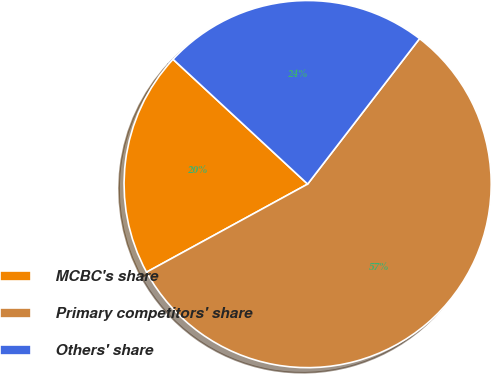Convert chart to OTSL. <chart><loc_0><loc_0><loc_500><loc_500><pie_chart><fcel>MCBC's share<fcel>Primary competitors' share<fcel>Others' share<nl><fcel>19.86%<fcel>56.6%<fcel>23.54%<nl></chart> 